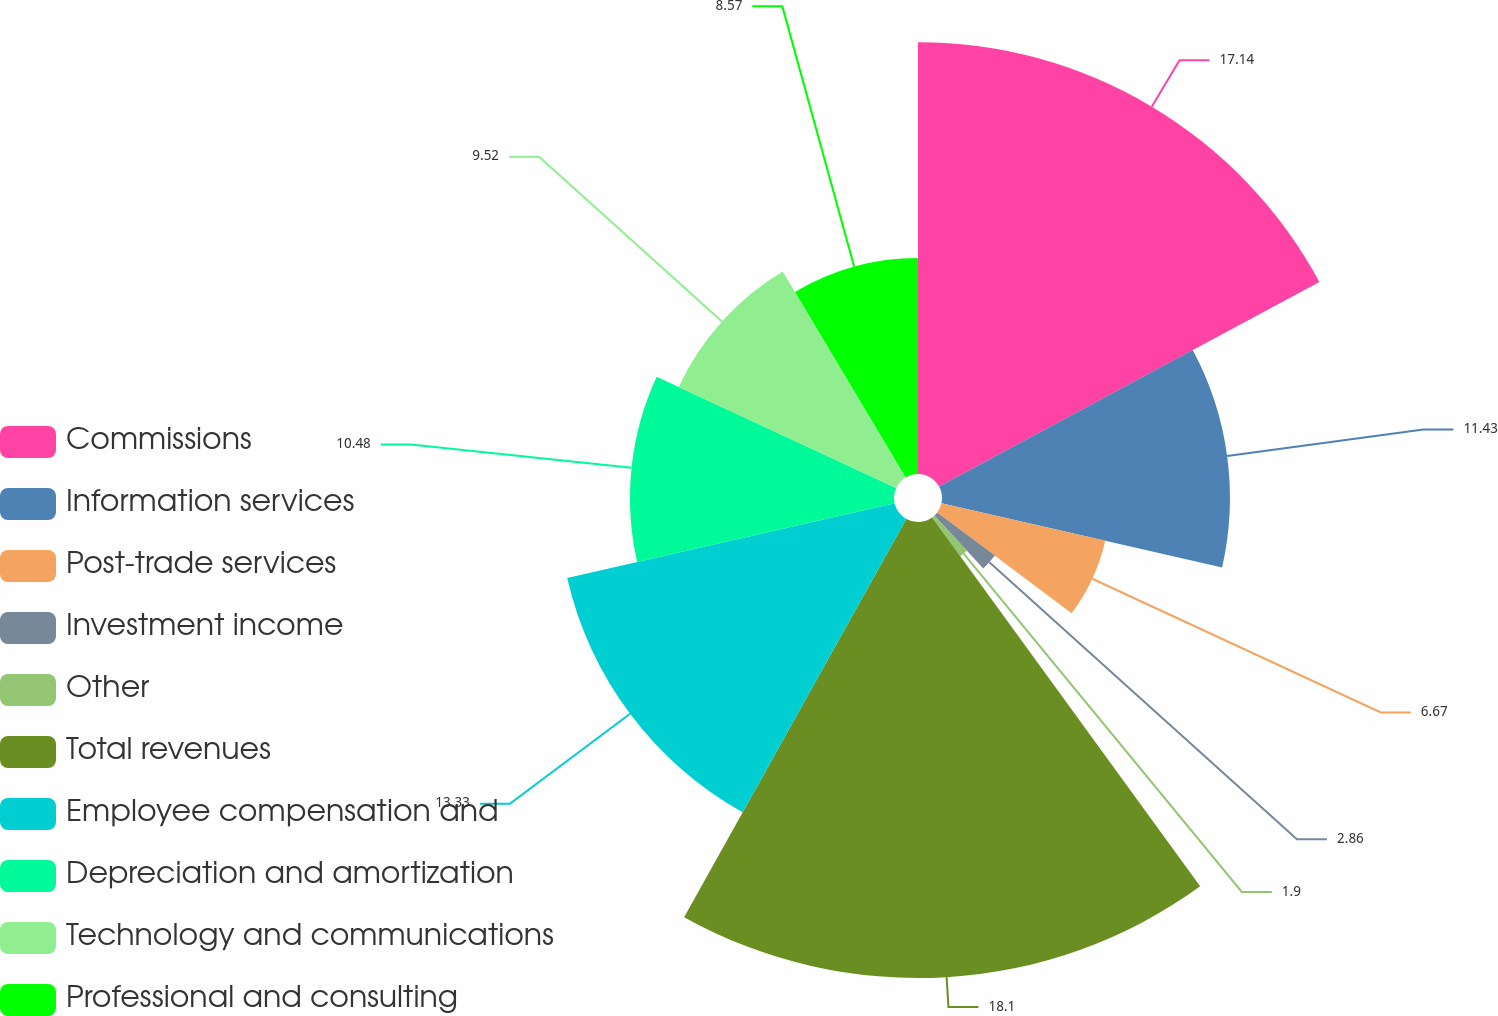<chart> <loc_0><loc_0><loc_500><loc_500><pie_chart><fcel>Commissions<fcel>Information services<fcel>Post-trade services<fcel>Investment income<fcel>Other<fcel>Total revenues<fcel>Employee compensation and<fcel>Depreciation and amortization<fcel>Technology and communications<fcel>Professional and consulting<nl><fcel>17.14%<fcel>11.43%<fcel>6.67%<fcel>2.86%<fcel>1.9%<fcel>18.1%<fcel>13.33%<fcel>10.48%<fcel>9.52%<fcel>8.57%<nl></chart> 